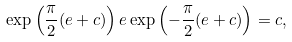<formula> <loc_0><loc_0><loc_500><loc_500>\exp \left ( \frac { \pi } { 2 } ( e + c ) \right ) e \exp \left ( - \frac { \pi } { 2 } ( e + c ) \right ) = c ,</formula> 